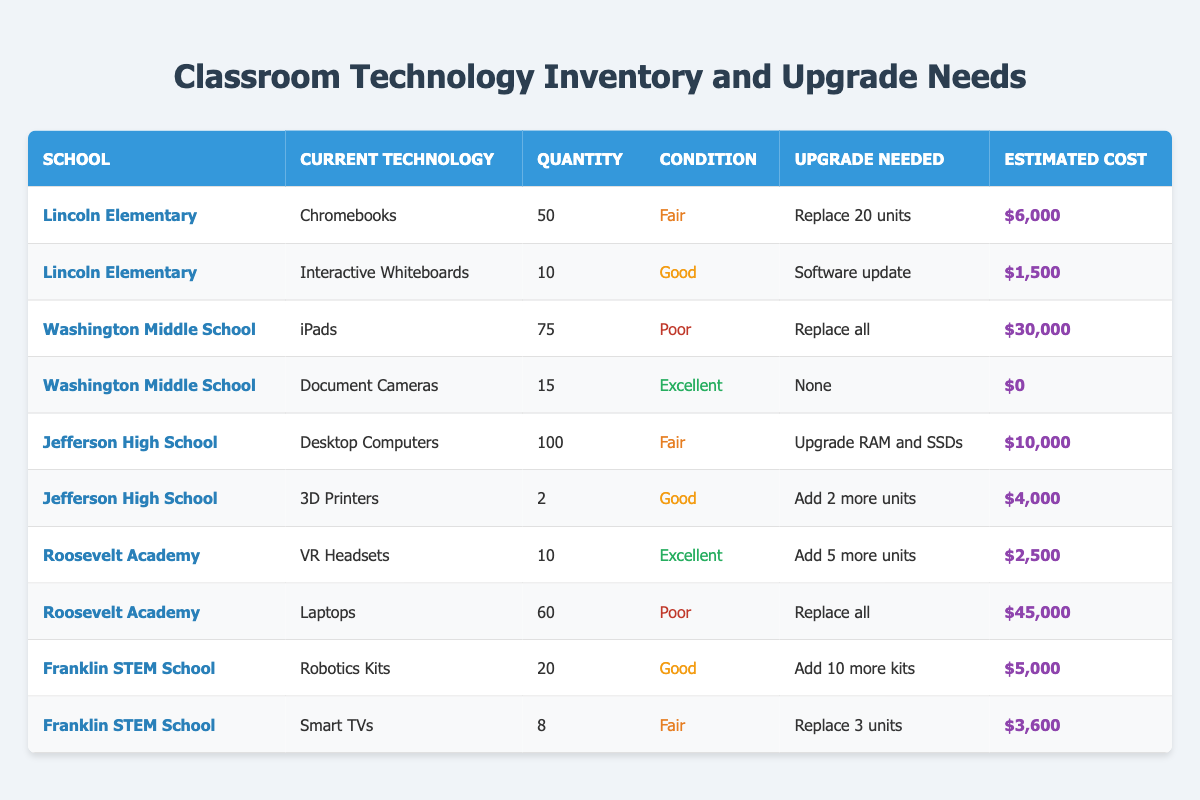what is the estimated cost to replace all the iPads at Washington Middle School? The table shows that the estimated cost for replacing all the iPads at Washington Middle School is listed as $30,000.
Answer: $30,000 how many units of Chromebooks need to be replaced at Lincoln Elementary? The table indicates that Lincoln Elementary needs to replace 20 units of Chromebooks.
Answer: 20 units which school has the highest estimated cost for technology upgrades? By comparing the estimated costs listed in the table, Roosevelt Academy has the highest estimated cost of $45,000 for replacing all laptops.
Answer: $45,000 how many total interactive whiteboards and document cameras are listed in the table? The table shows 10 interactive whiteboards at Lincoln Elementary and 15 document cameras at Washington Middle School. Adding these gives a total of 25 units (10 + 15 = 25).
Answer: 25 units is there any technology listed in excellent condition that does not need an upgrade? The table indicates that the document cameras at Washington Middle School are in excellent condition and do not require an upgrade, as their upgrade needed is "None."
Answer: Yes how much is the total estimated cost for upgrading the technology at Franklin STEM School? At Franklin STEM School, the upgrade needs include adding 10 more robotics kits (estimated cost $5,000) and replacing 3 smart TVs (estimated cost $3,600). The total estimated cost is calculated by adding these amounts: $5,000 + $3,600 = $8,600.
Answer: $8,600 how many more VR headsets are needed at Roosevelt Academy? The table states that Roosevelt Academy currently has 10 VR headsets and needs to add 5 more units, therefore the number of additional VR headsets needed is 5.
Answer: 5 headsets is the condition of desktop computers at Jefferson High School better than that of laptops at Roosevelt Academy? The desktop computers at Jefferson High School are in fair condition, while the laptops at Roosevelt Academy are in poor condition. Since fair is better than poor, the answer is yes, desktop computers are in better condition.
Answer: Yes what percentage of the total current quantity of laptops are designated for replacement at Roosevelt Academy? There are 60 laptops at Roosevelt Academy, and the table indicates that they need to be replaced entirely. To find the percentage, we take the quantity needing replacement (60) and divide it by the total quantity (60), then multiply by 100: (60/60) * 100 = 100%.
Answer: 100% 